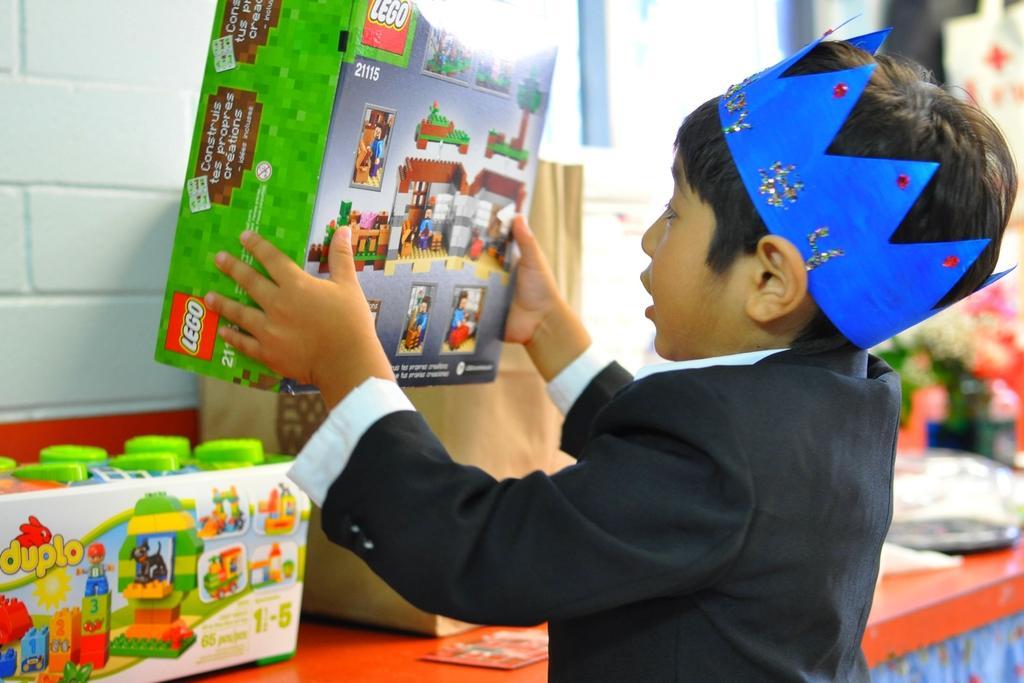Please provide a concise description of this image. In this image there is one kid standing on the right side of this image is wearing a black color blazer and holding an object. There is a table in the bottom of this image and there are some objects kept on it. There is a wall in the background. 